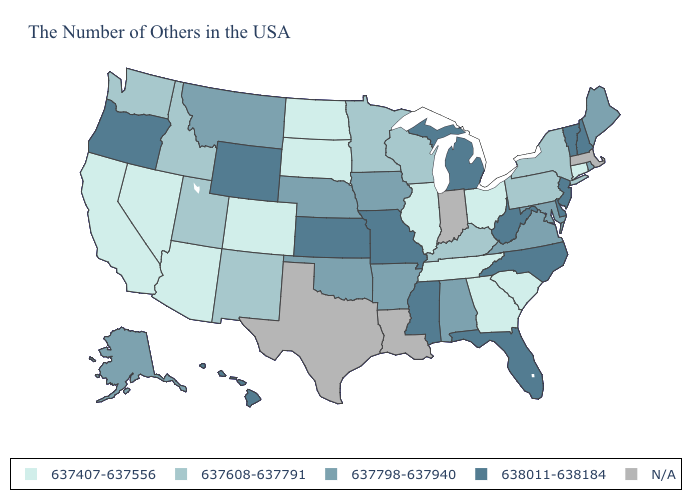Does North Dakota have the highest value in the MidWest?
Answer briefly. No. Name the states that have a value in the range 637407-637556?
Give a very brief answer. Connecticut, South Carolina, Ohio, Georgia, Tennessee, Illinois, South Dakota, North Dakota, Colorado, Arizona, Nevada, California. What is the value of South Carolina?
Give a very brief answer. 637407-637556. Among the states that border Arkansas , does Tennessee have the highest value?
Keep it brief. No. Does New York have the lowest value in the Northeast?
Write a very short answer. No. Is the legend a continuous bar?
Be succinct. No. Does the map have missing data?
Write a very short answer. Yes. Which states have the lowest value in the USA?
Keep it brief. Connecticut, South Carolina, Ohio, Georgia, Tennessee, Illinois, South Dakota, North Dakota, Colorado, Arizona, Nevada, California. Name the states that have a value in the range 637798-637940?
Write a very short answer. Maine, Rhode Island, Maryland, Virginia, Alabama, Arkansas, Iowa, Nebraska, Oklahoma, Montana, Alaska. What is the value of Maine?
Keep it brief. 637798-637940. Which states have the lowest value in the West?
Concise answer only. Colorado, Arizona, Nevada, California. How many symbols are there in the legend?
Quick response, please. 5. Does the first symbol in the legend represent the smallest category?
Concise answer only. Yes. What is the highest value in the Northeast ?
Give a very brief answer. 638011-638184. 